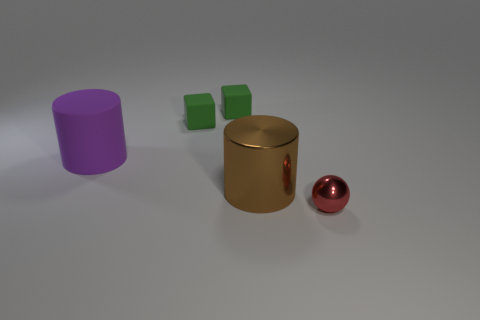The small metal thing is what color?
Offer a very short reply. Red. Is there a big rubber object that is on the left side of the big cylinder that is right of the purple matte cylinder?
Ensure brevity in your answer.  Yes. What material is the purple cylinder?
Your response must be concise. Rubber. Is the material of the large object that is to the left of the large brown metal object the same as the object on the right side of the large brown metal object?
Your answer should be very brief. No. Is there anything else of the same color as the metallic sphere?
Keep it short and to the point. No. What color is the large matte thing that is the same shape as the big brown shiny thing?
Give a very brief answer. Purple. What size is the thing that is in front of the purple thing and behind the red shiny ball?
Provide a succinct answer. Large. There is a metallic thing left of the red metal ball; is it the same shape as the large object that is behind the big brown thing?
Provide a succinct answer. Yes. What number of small red spheres have the same material as the purple cylinder?
Your answer should be very brief. 0. There is a thing that is in front of the big matte thing and to the left of the red object; what shape is it?
Your response must be concise. Cylinder. 